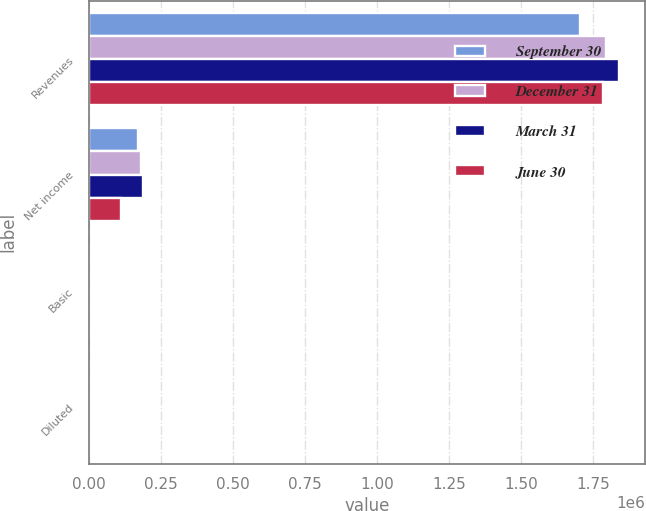Convert chart. <chart><loc_0><loc_0><loc_500><loc_500><stacked_bar_chart><ecel><fcel>Revenues<fcel>Net income<fcel>Basic<fcel>Diluted<nl><fcel>September 30<fcel>1.70691e+06<fcel>169673<fcel>1.31<fcel>1.25<nl><fcel>December 31<fcel>1.79699e+06<fcel>179961<fcel>1.41<fcel>1.35<nl><fcel>March 31<fcel>1.8406e+06<fcel>188539<fcel>1.48<fcel>1.42<nl><fcel>June 30<fcel>1.78443e+06<fcel>110711<fcel>0.87<fcel>0.83<nl></chart> 